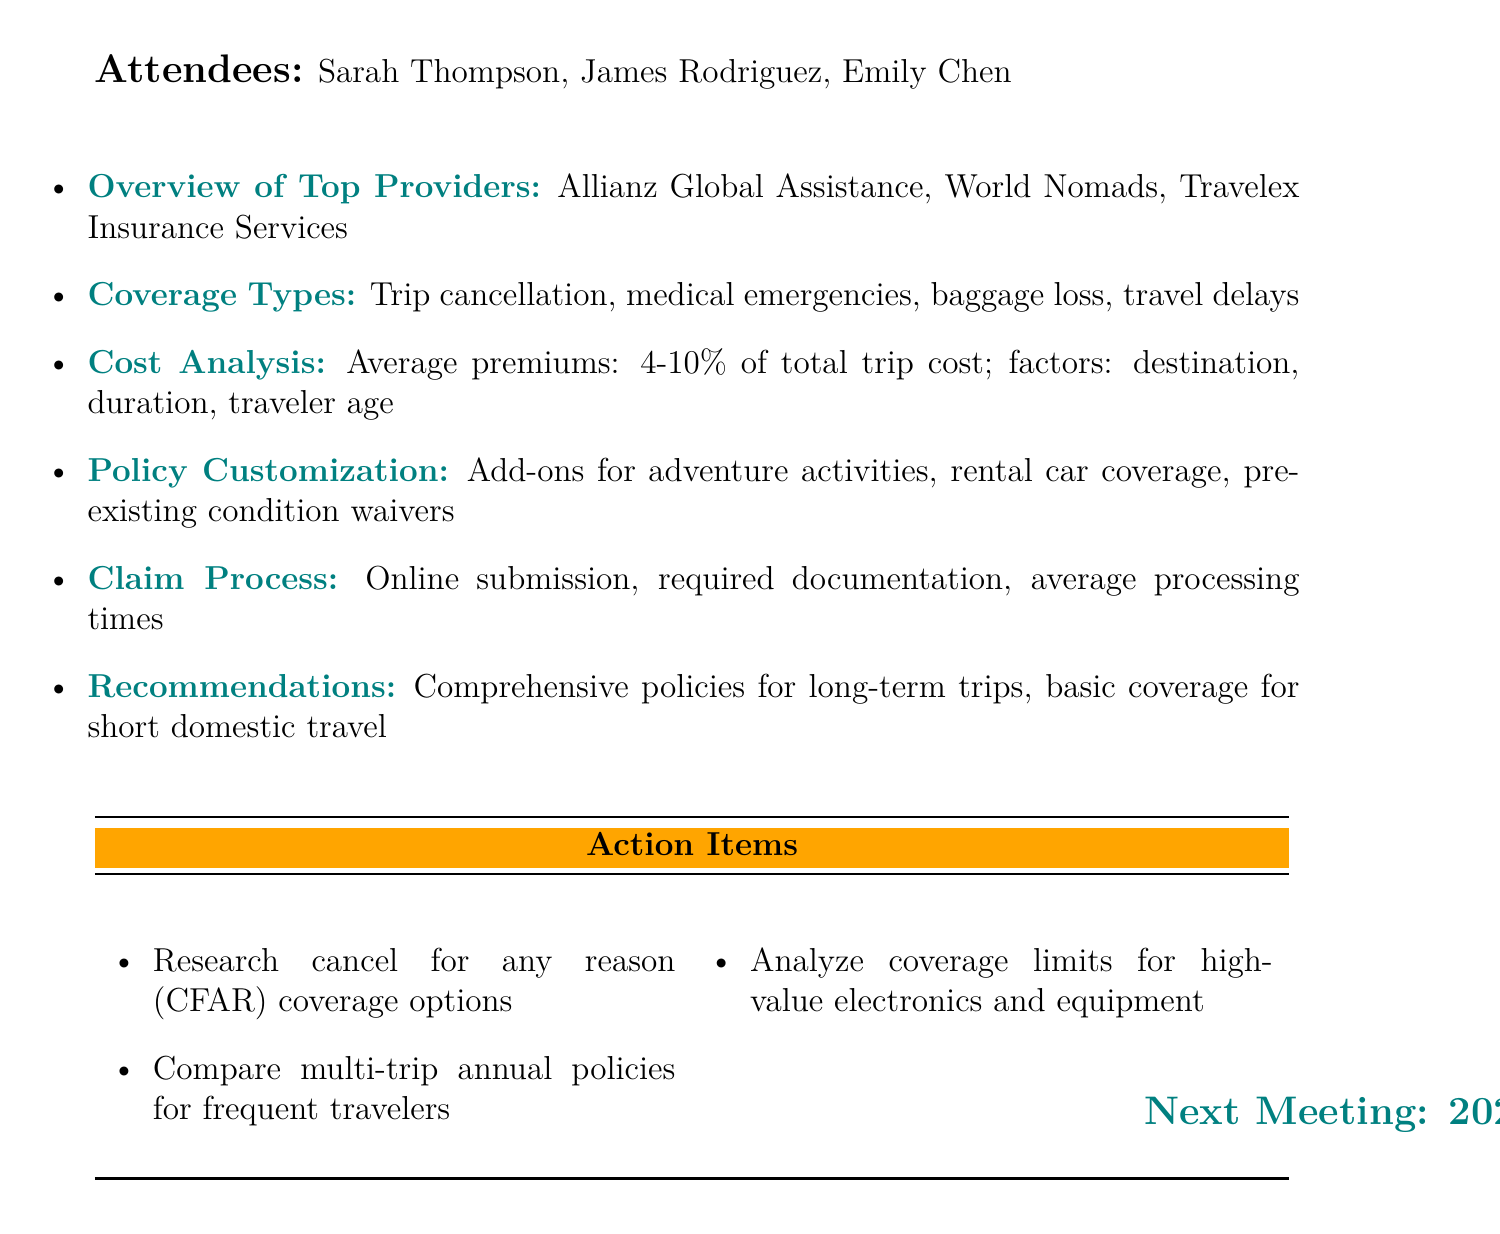What is the meeting title? The meeting title is stated at the top of the document.
Answer: Comprehensive Travel Insurance Analysis for Planned Trips Who is the insurance analyst? The attendees' names and roles are listed in the document.
Answer: James Rodriguez What are the top travel insurance providers? The overview section lists the names of providers.
Answer: Allianz Global Assistance, World Nomads, Travelex Insurance Services What is the average premium range for travel insurance? The cost analysis section provides this information.
Answer: 4-10 percent of total trip cost What policy customization options are mentioned? This information is contained under the policy customization options in the agenda.
Answer: Add-ons for adventure activities, rental car coverage, pre-existing condition waivers What is the recommendation for long-term trips? The recommendations section provides this crucial insight.
Answer: Comprehensive policies for long-term trips What is one action item discussed for the next meeting? The action items listed after the agenda items specify tasks to be completed.
Answer: Research cancel for any reason (CFAR) coverage options When is the next meeting scheduled? This information is explicitly stated at the bottom of the document.
Answer: 2023-05-29 